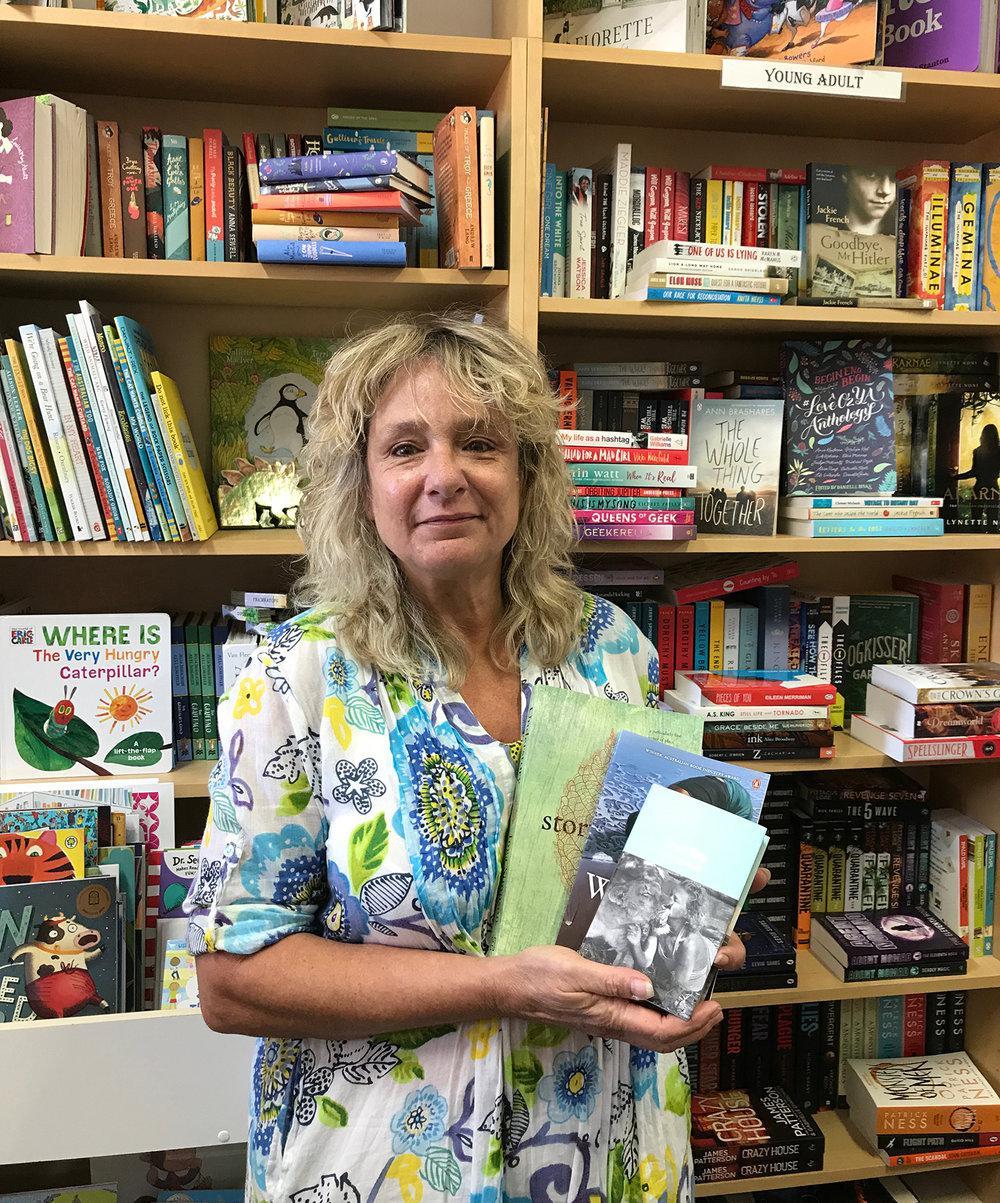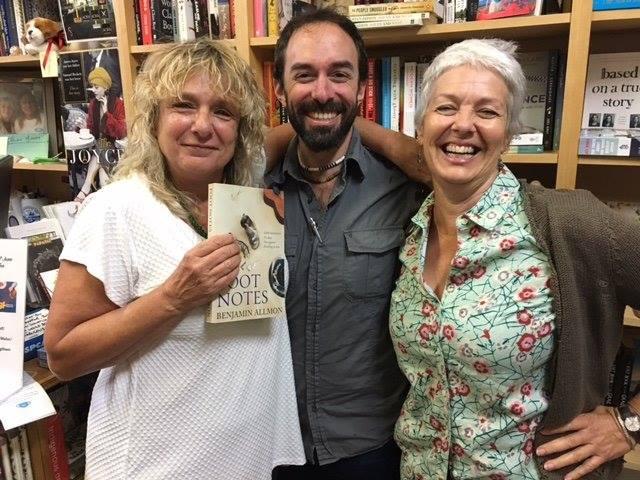The first image is the image on the left, the second image is the image on the right. Analyze the images presented: Is the assertion "In one image, a blond woman has an arm around the man next to her, and a woman on the other side of him has her elbow bent, and they are standing in front of books on shelves." valid? Answer yes or no. Yes. The first image is the image on the left, the second image is the image on the right. Assess this claim about the two images: "An author is posing with fans.". Correct or not? Answer yes or no. Yes. 